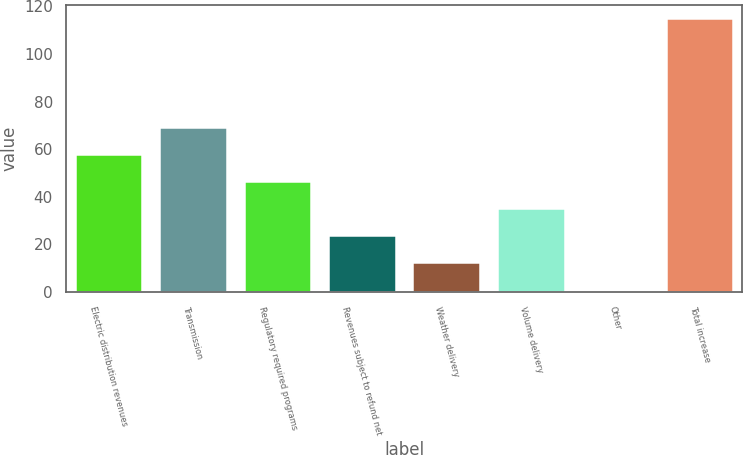<chart> <loc_0><loc_0><loc_500><loc_500><bar_chart><fcel>Electric distribution revenues<fcel>Transmission<fcel>Regulatory required programs<fcel>Revenues subject to refund net<fcel>Weather delivery<fcel>Volume delivery<fcel>Other<fcel>Total increase<nl><fcel>58<fcel>69.4<fcel>46.6<fcel>23.8<fcel>12.4<fcel>35.2<fcel>1<fcel>115<nl></chart> 